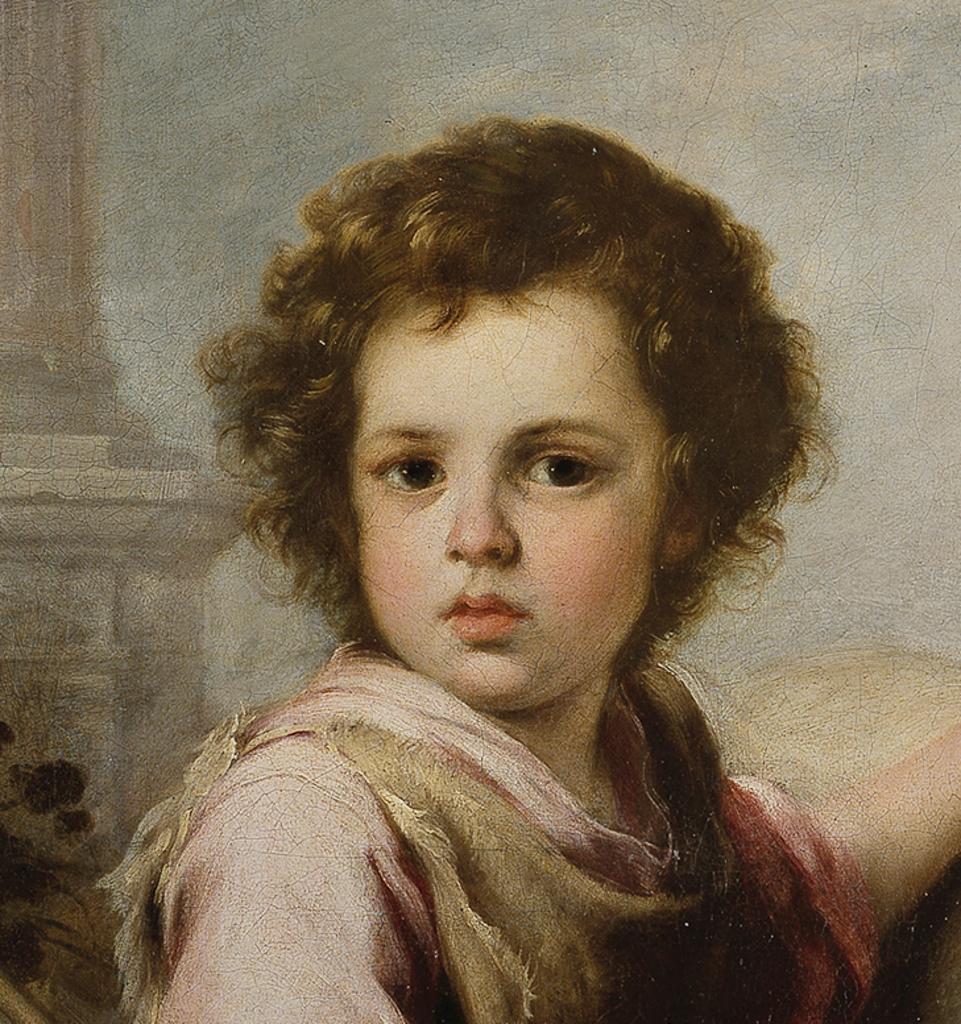How would you summarize this image in a sentence or two? In this picture we can see painting of a kid. 